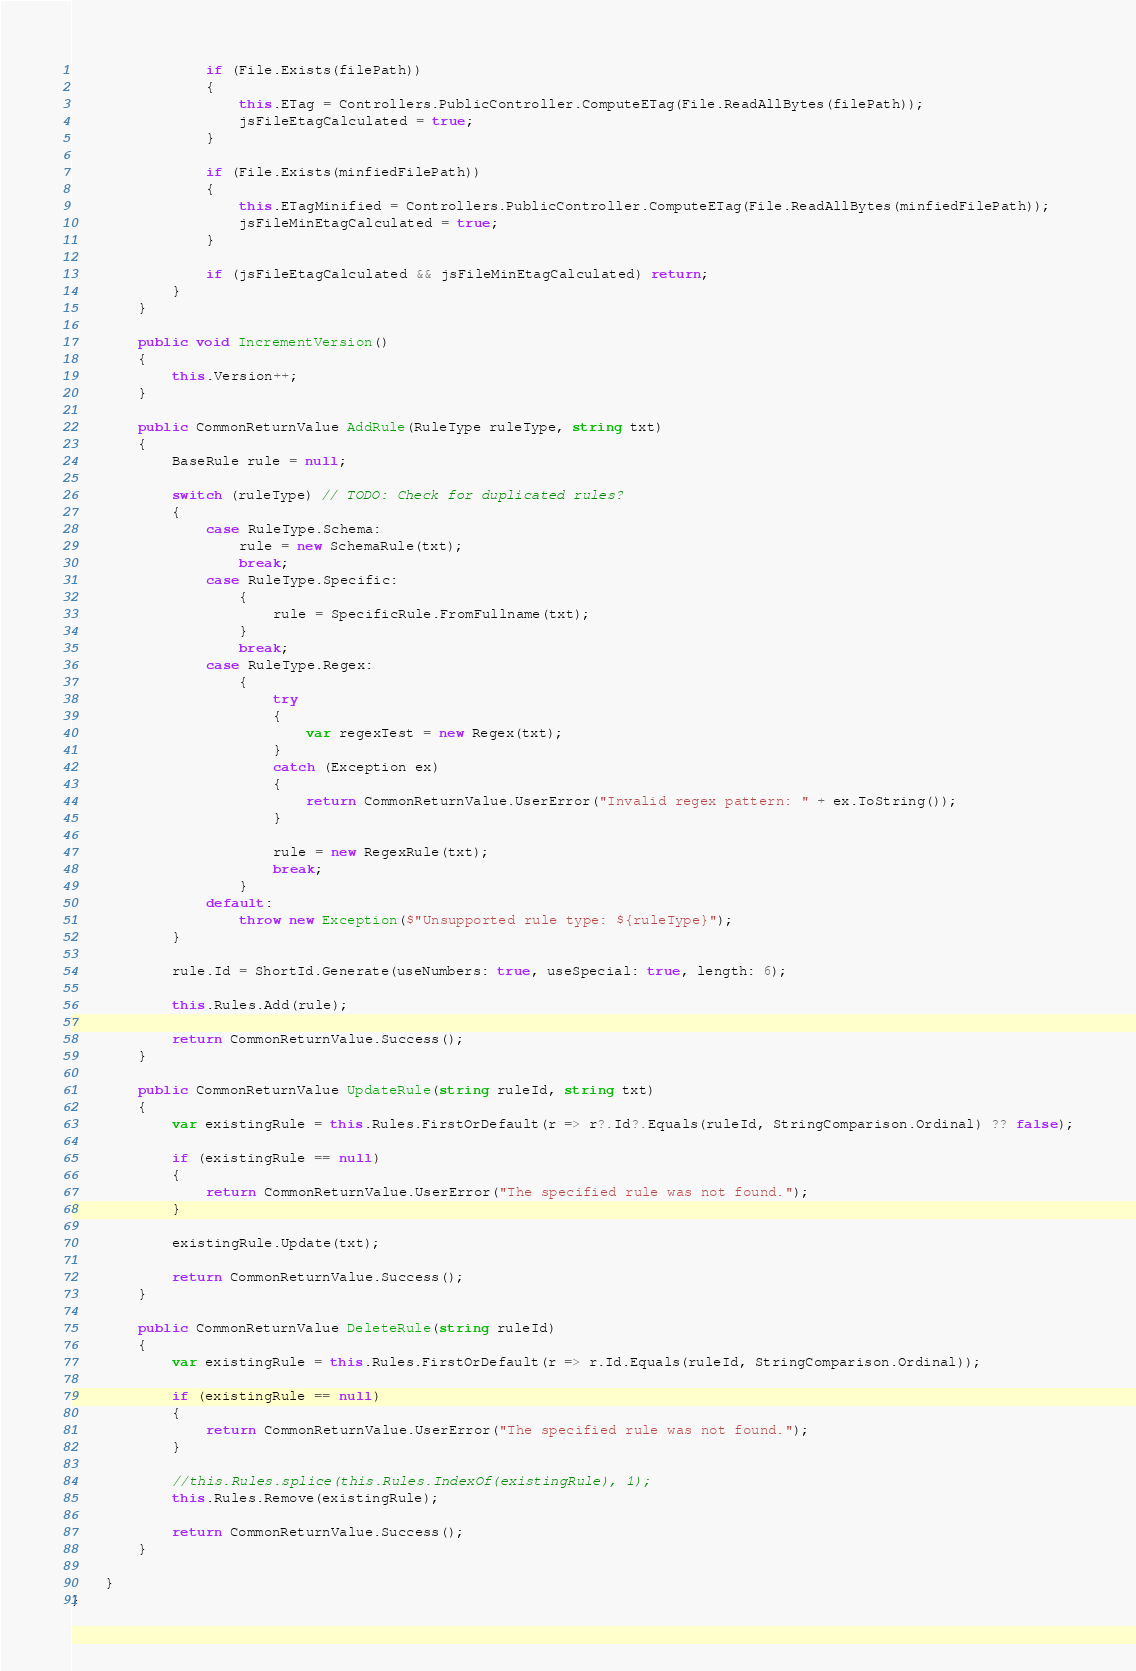Convert code to text. <code><loc_0><loc_0><loc_500><loc_500><_C#_>
                if (File.Exists(filePath))
                {
                    this.ETag = Controllers.PublicController.ComputeETag(File.ReadAllBytes(filePath));
                    jsFileEtagCalculated = true;
                }

                if (File.Exists(minfiedFilePath))
                {
                    this.ETagMinified = Controllers.PublicController.ComputeETag(File.ReadAllBytes(minfiedFilePath));
                    jsFileMinEtagCalculated = true;
                }

                if (jsFileEtagCalculated && jsFileMinEtagCalculated) return;
            }
        }

        public void IncrementVersion()
        {
            this.Version++;
        }

        public CommonReturnValue AddRule(RuleType ruleType, string txt)
        {
            BaseRule rule = null;

            switch (ruleType) // TODO: Check for duplicated rules?
            {
                case RuleType.Schema:
                    rule = new SchemaRule(txt);
                    break;
                case RuleType.Specific:
                    {
                        rule = SpecificRule.FromFullname(txt);
                    }
                    break;
                case RuleType.Regex:
                    {
                        try
                        {
                            var regexTest = new Regex(txt);
                        }
                        catch (Exception ex)
                        {
                            return CommonReturnValue.UserError("Invalid regex pattern: " + ex.ToString());
                        }

                        rule = new RegexRule(txt);
                        break;
                    }
                default:
                    throw new Exception($"Unsupported rule type: ${ruleType}");
            }

            rule.Id = ShortId.Generate(useNumbers: true, useSpecial: true, length: 6);

            this.Rules.Add(rule);

            return CommonReturnValue.Success();
        }

        public CommonReturnValue UpdateRule(string ruleId, string txt)
        {
            var existingRule = this.Rules.FirstOrDefault(r => r?.Id?.Equals(ruleId, StringComparison.Ordinal) ?? false);

            if (existingRule == null)
            {
                return CommonReturnValue.UserError("The specified rule was not found.");
            }

            existingRule.Update(txt);

            return CommonReturnValue.Success();
        }

        public CommonReturnValue DeleteRule(string ruleId)
        {
            var existingRule = this.Rules.FirstOrDefault(r => r.Id.Equals(ruleId, StringComparison.Ordinal));

            if (existingRule == null)
            {
                return CommonReturnValue.UserError("The specified rule was not found.");
            }

            //this.Rules.splice(this.Rules.IndexOf(existingRule), 1);
            this.Rules.Remove(existingRule);

            return CommonReturnValue.Success();
        }

    }
}
</code> 